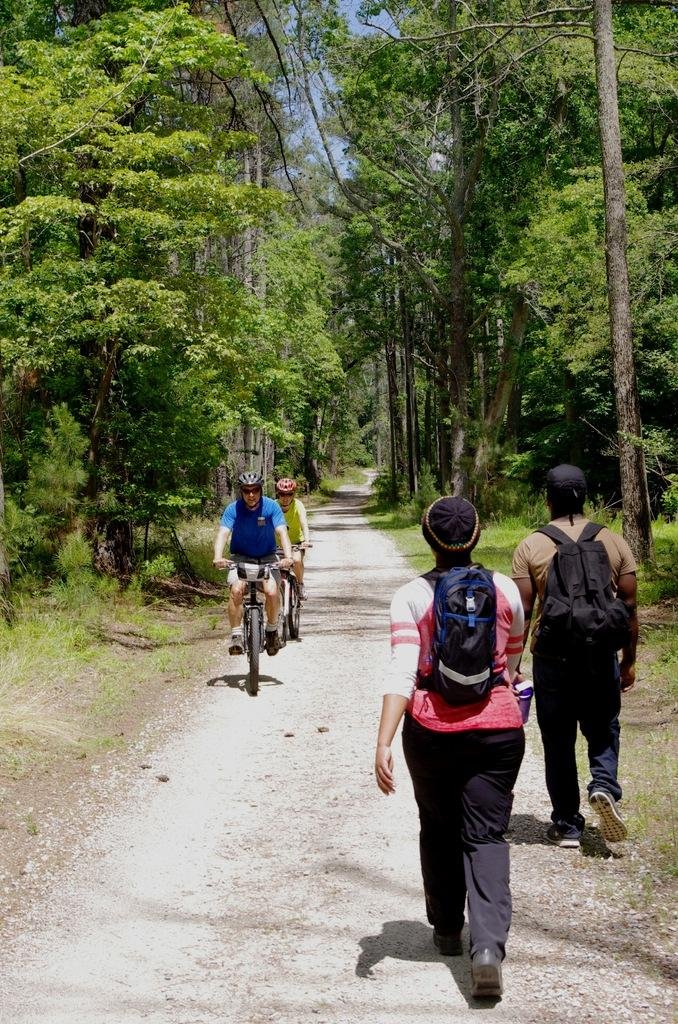What are the two persons on the right side of the image doing? The two persons on the right side of the image are walking. What are the two persons on the left side of the image doing? The two persons on the left side of the image are riding cycles. What type of vegetation can be seen in the image? There are green trees visible in the image. Where is the flame coming from in the image? There is no flame present in the image. What type of building can be seen in the background of the image? There is no building visible in the image. 